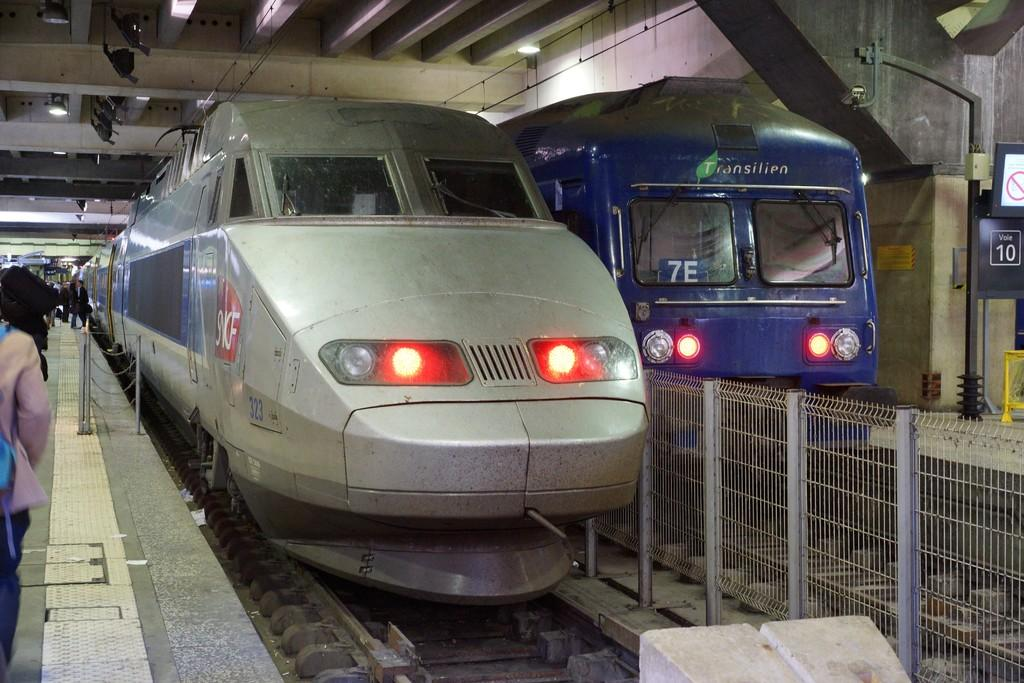<image>
Summarize the visual content of the image. A silver bullet type train next to a blue train that says 7E on it. 